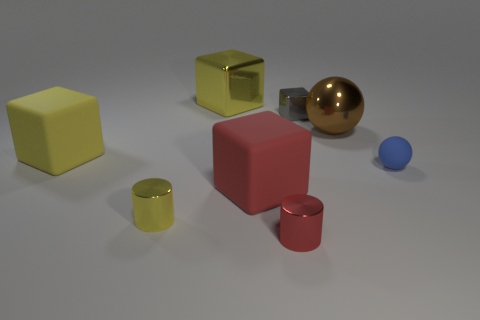Add 1 big red matte blocks. How many objects exist? 9 Subtract all cylinders. How many objects are left? 6 Add 3 large yellow objects. How many large yellow objects exist? 5 Subtract 0 green cylinders. How many objects are left? 8 Subtract all cylinders. Subtract all large red blocks. How many objects are left? 5 Add 5 metal cylinders. How many metal cylinders are left? 7 